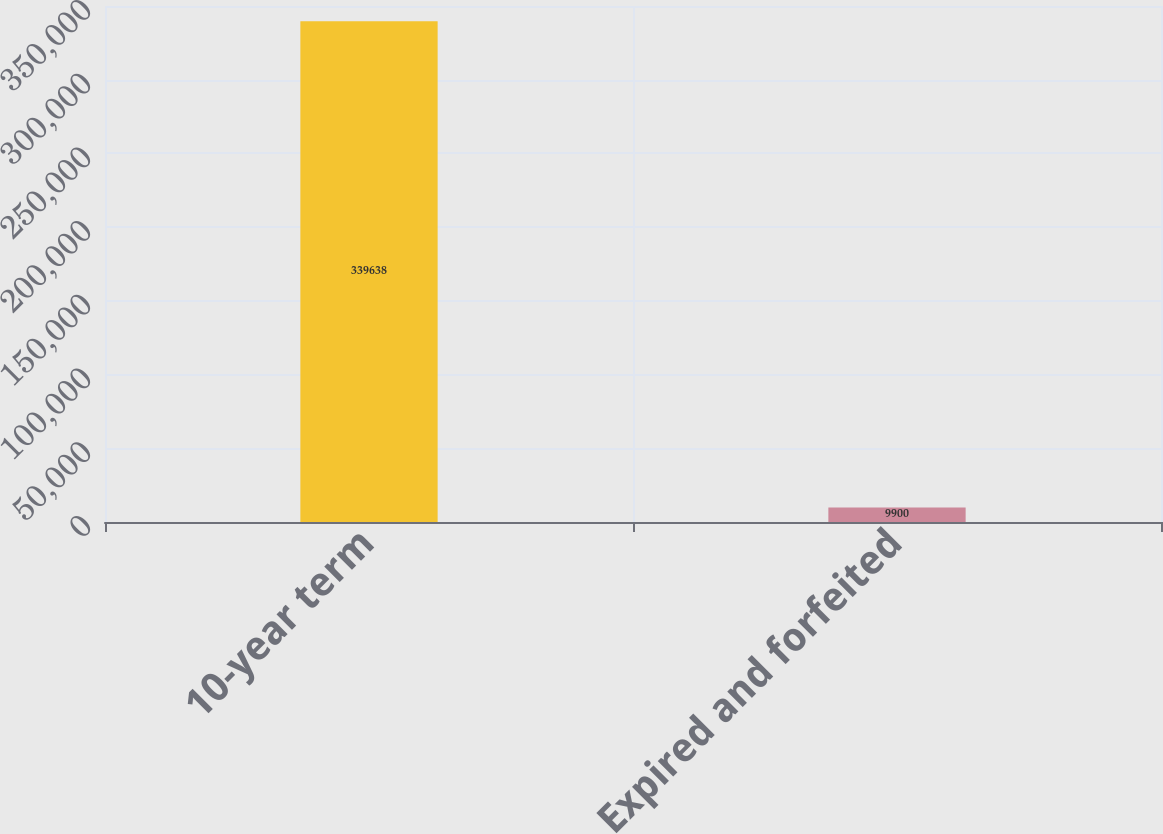Convert chart to OTSL. <chart><loc_0><loc_0><loc_500><loc_500><bar_chart><fcel>10-year term<fcel>Expired and forfeited<nl><fcel>339638<fcel>9900<nl></chart> 